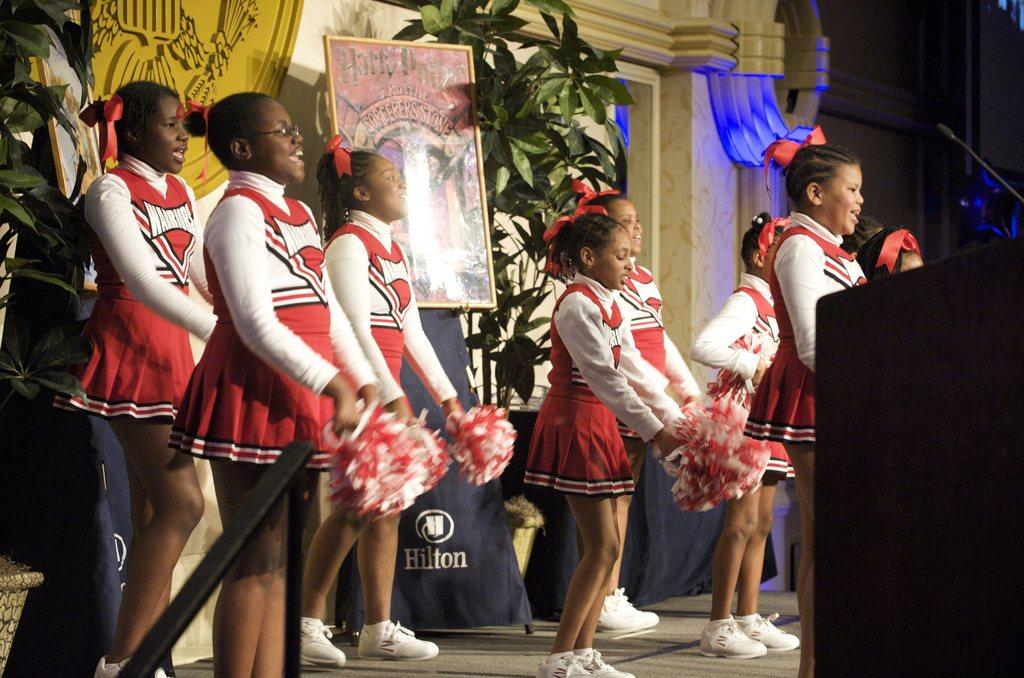<image>
Share a concise interpretation of the image provided. A Harry Potter sign hangs behind a group of girls. 